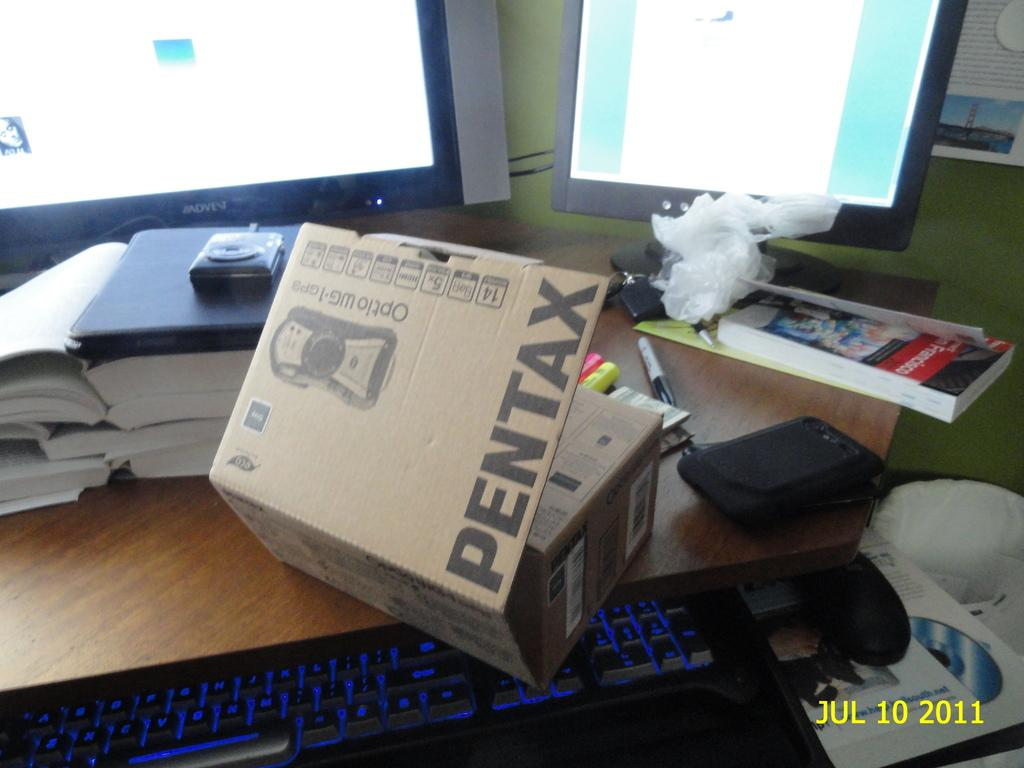<image>
Relay a brief, clear account of the picture shown. A Pentax box is partially opened on a table. 